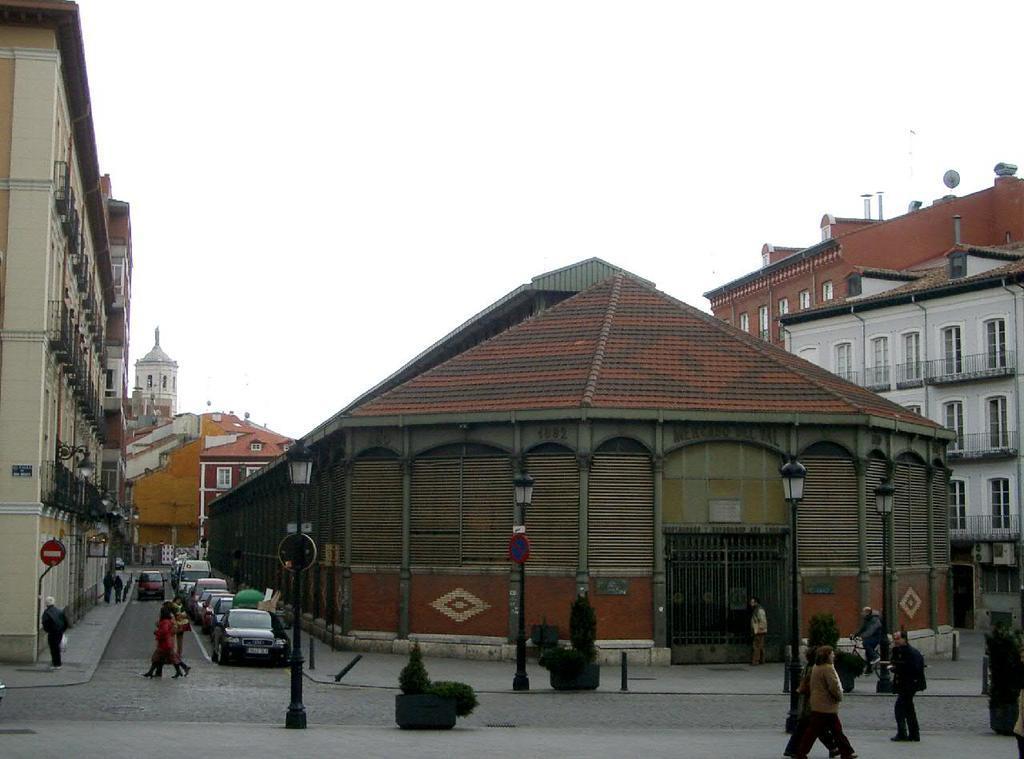Could you give a brief overview of what you see in this image? In this image, I can see groups of people walking and there are buildings. At the bottom of the image, I can see the light poles and there are plants in the flower pots. There are vehicles on the road. In the background, I can see the sky. 